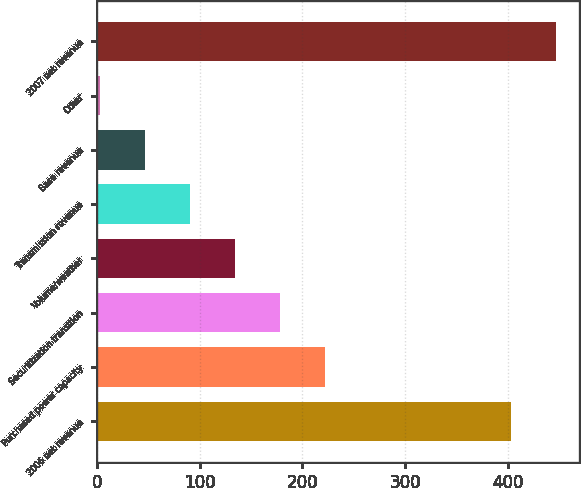Convert chart. <chart><loc_0><loc_0><loc_500><loc_500><bar_chart><fcel>2006 net revenue<fcel>Purchased power capacity<fcel>Securitization transition<fcel>Volume/weather<fcel>Transmission revenue<fcel>Base revenue<fcel>Other<fcel>2007 net revenue<nl><fcel>403.3<fcel>222.35<fcel>178.36<fcel>134.37<fcel>90.38<fcel>46.39<fcel>2.4<fcel>447.29<nl></chart> 